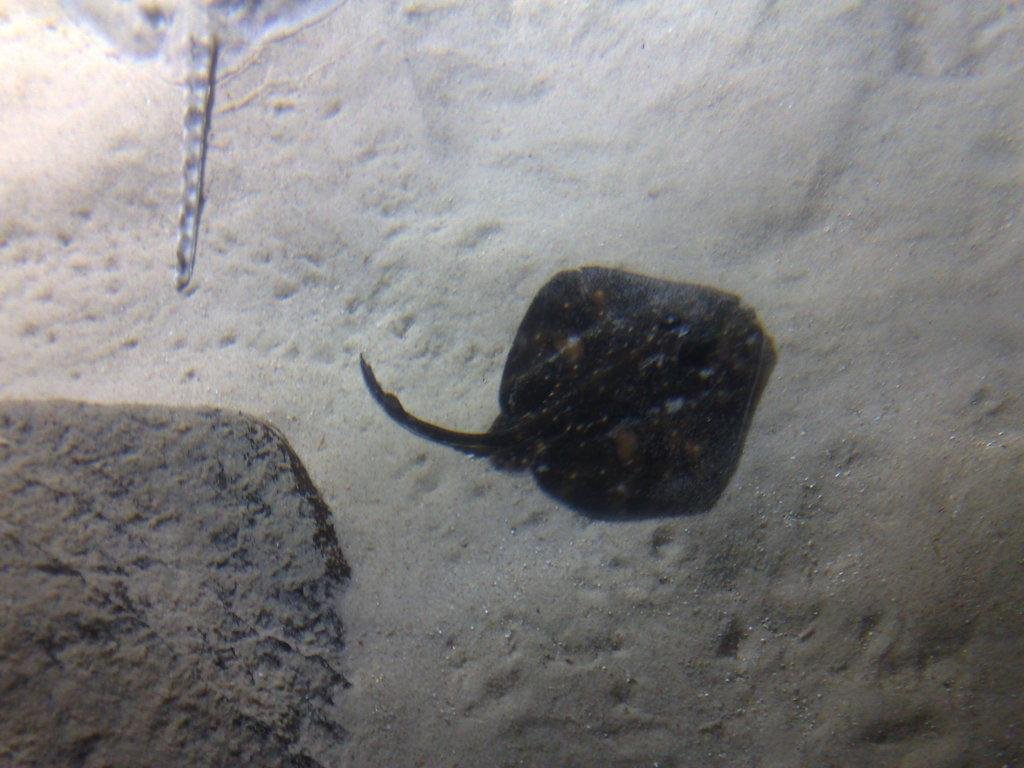What is the setting of the image? The image appears to be taken in water. What can be seen in the middle of the image? There is an aquatic animal in the middle of the image. What is the color of the aquatic animal? The aquatic animal is black in color. What is located to the left of the image? There is a rock to the left of the image. What is the date on the calendar in the image? There is no calendar present in the image. Can you describe the elbow of the aquatic animal in the image? Aquatic animals do not have elbows, as they are not mammals with limbs like humans. 